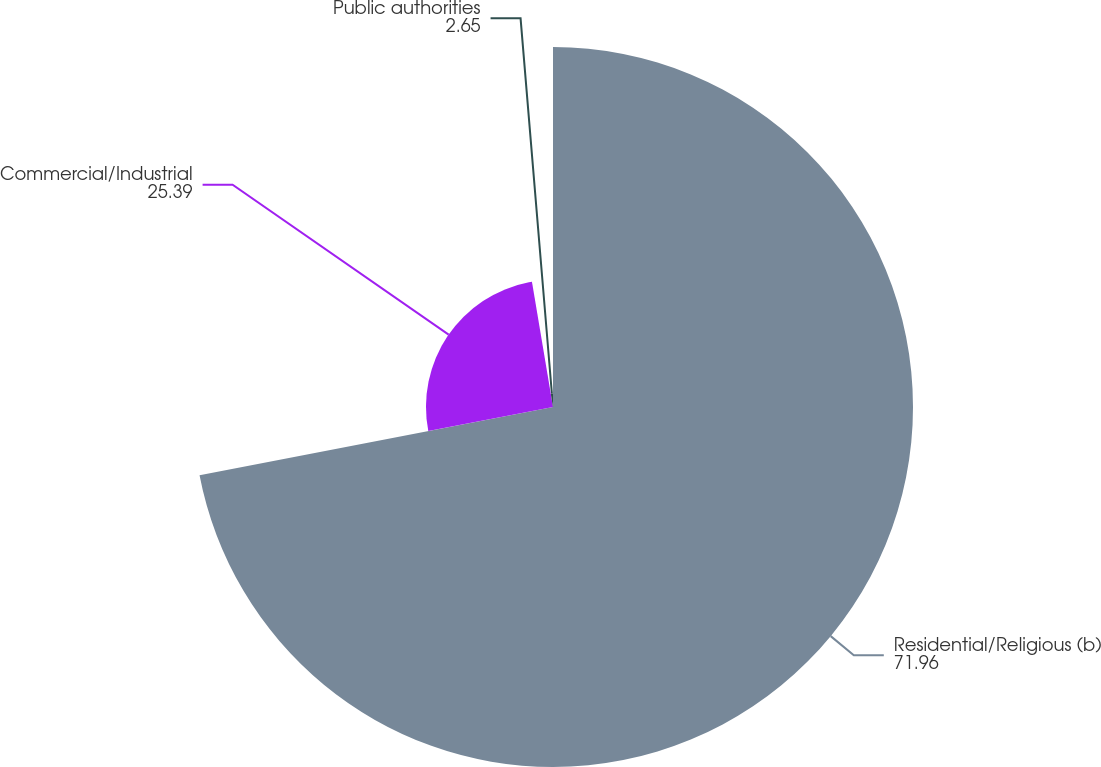<chart> <loc_0><loc_0><loc_500><loc_500><pie_chart><fcel>Residential/Religious (b)<fcel>Commercial/Industrial<fcel>Public authorities<nl><fcel>71.96%<fcel>25.39%<fcel>2.65%<nl></chart> 